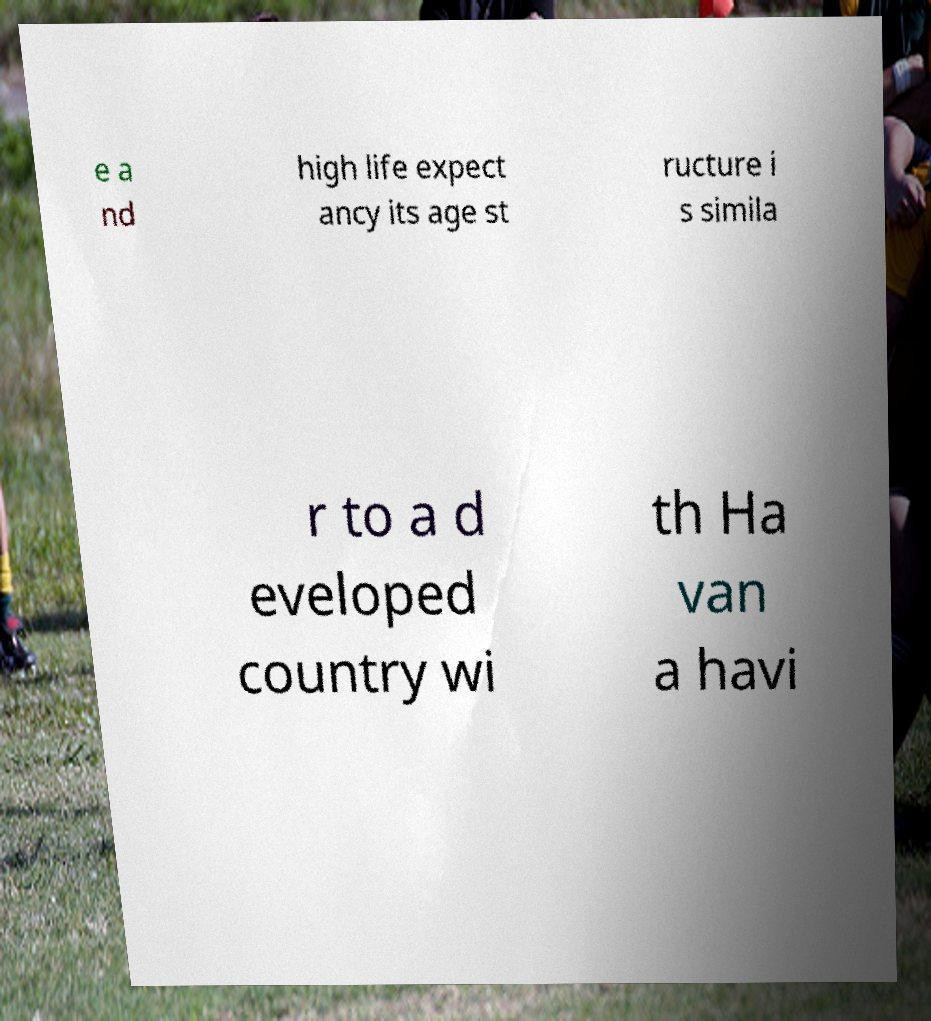What messages or text are displayed in this image? I need them in a readable, typed format. e a nd high life expect ancy its age st ructure i s simila r to a d eveloped country wi th Ha van a havi 